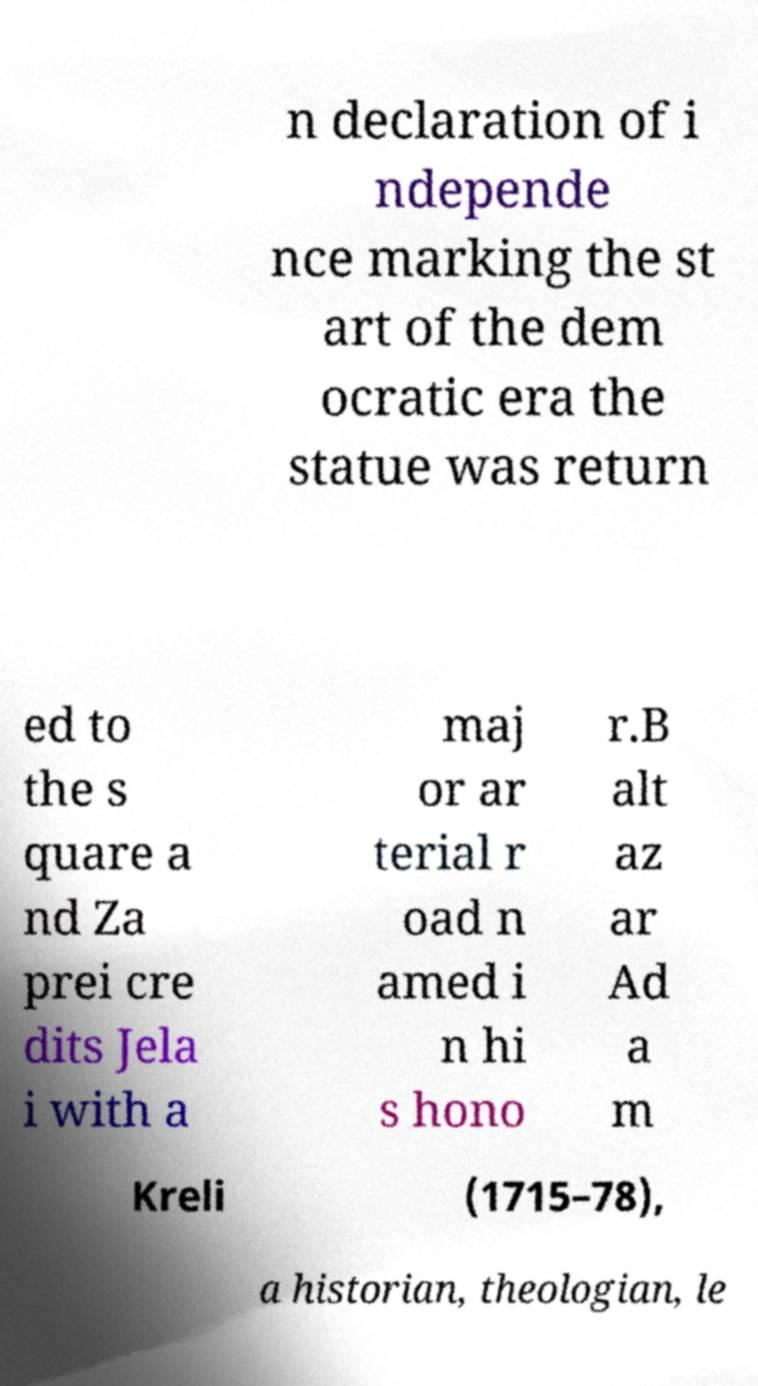Could you assist in decoding the text presented in this image and type it out clearly? n declaration of i ndepende nce marking the st art of the dem ocratic era the statue was return ed to the s quare a nd Za prei cre dits Jela i with a maj or ar terial r oad n amed i n hi s hono r.B alt az ar Ad a m Kreli (1715–78), a historian, theologian, le 